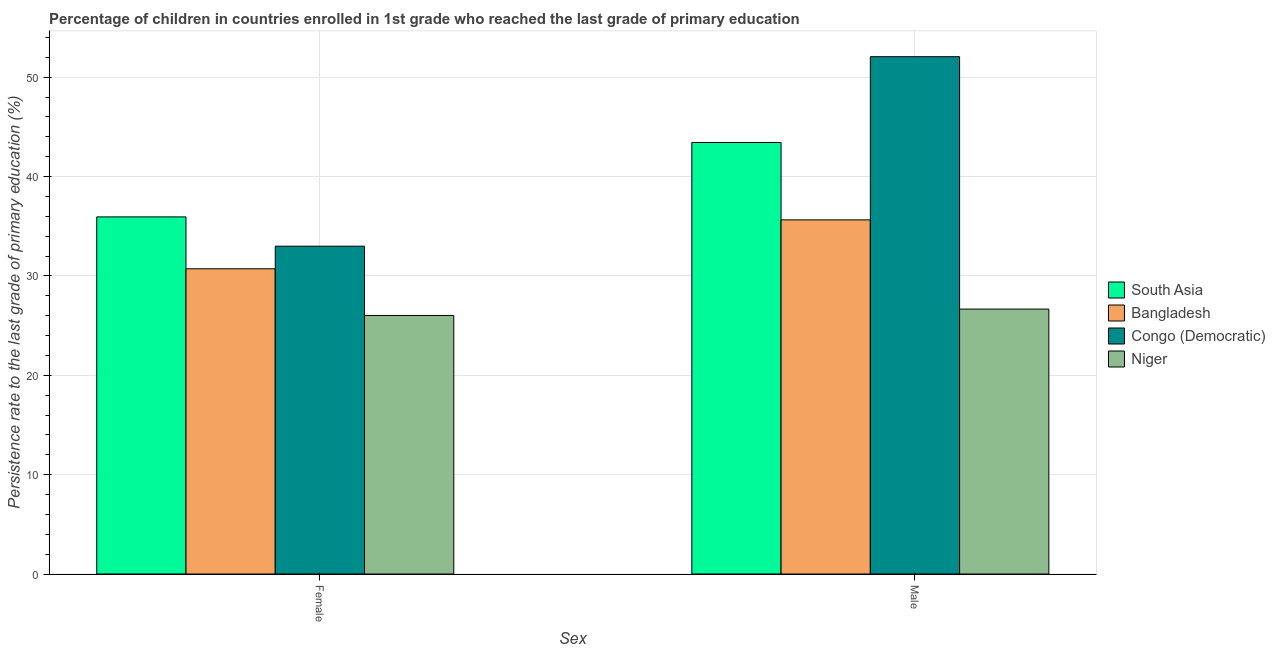Are the number of bars per tick equal to the number of legend labels?
Provide a short and direct response. Yes. What is the label of the 1st group of bars from the left?
Make the answer very short. Female. What is the persistence rate of female students in South Asia?
Offer a very short reply. 35.94. Across all countries, what is the maximum persistence rate of male students?
Keep it short and to the point. 52.06. Across all countries, what is the minimum persistence rate of female students?
Your response must be concise. 26.02. In which country was the persistence rate of female students maximum?
Provide a short and direct response. South Asia. In which country was the persistence rate of female students minimum?
Make the answer very short. Niger. What is the total persistence rate of male students in the graph?
Offer a terse response. 157.78. What is the difference between the persistence rate of female students in Bangladesh and that in Congo (Democratic)?
Make the answer very short. -2.27. What is the difference between the persistence rate of male students in Niger and the persistence rate of female students in Congo (Democratic)?
Make the answer very short. -6.33. What is the average persistence rate of male students per country?
Offer a terse response. 39.44. What is the difference between the persistence rate of female students and persistence rate of male students in Niger?
Provide a short and direct response. -0.64. In how many countries, is the persistence rate of male students greater than 10 %?
Your answer should be very brief. 4. What is the ratio of the persistence rate of male students in South Asia to that in Congo (Democratic)?
Ensure brevity in your answer.  0.83. Is the persistence rate of male students in South Asia less than that in Congo (Democratic)?
Ensure brevity in your answer.  Yes. In how many countries, is the persistence rate of male students greater than the average persistence rate of male students taken over all countries?
Your response must be concise. 2. What does the 1st bar from the left in Female represents?
Your response must be concise. South Asia. What does the 2nd bar from the right in Male represents?
Make the answer very short. Congo (Democratic). How many bars are there?
Your answer should be compact. 8. What is the difference between two consecutive major ticks on the Y-axis?
Your answer should be very brief. 10. Are the values on the major ticks of Y-axis written in scientific E-notation?
Give a very brief answer. No. How are the legend labels stacked?
Your answer should be very brief. Vertical. What is the title of the graph?
Your answer should be very brief. Percentage of children in countries enrolled in 1st grade who reached the last grade of primary education. Does "Middle East & North Africa (developing only)" appear as one of the legend labels in the graph?
Ensure brevity in your answer.  No. What is the label or title of the X-axis?
Give a very brief answer. Sex. What is the label or title of the Y-axis?
Keep it short and to the point. Persistence rate to the last grade of primary education (%). What is the Persistence rate to the last grade of primary education (%) of South Asia in Female?
Provide a short and direct response. 35.94. What is the Persistence rate to the last grade of primary education (%) in Bangladesh in Female?
Your answer should be very brief. 30.71. What is the Persistence rate to the last grade of primary education (%) of Congo (Democratic) in Female?
Provide a succinct answer. 32.99. What is the Persistence rate to the last grade of primary education (%) of Niger in Female?
Provide a succinct answer. 26.02. What is the Persistence rate to the last grade of primary education (%) in South Asia in Male?
Give a very brief answer. 43.42. What is the Persistence rate to the last grade of primary education (%) of Bangladesh in Male?
Provide a succinct answer. 35.64. What is the Persistence rate to the last grade of primary education (%) of Congo (Democratic) in Male?
Provide a short and direct response. 52.06. What is the Persistence rate to the last grade of primary education (%) of Niger in Male?
Provide a succinct answer. 26.66. Across all Sex, what is the maximum Persistence rate to the last grade of primary education (%) of South Asia?
Provide a succinct answer. 43.42. Across all Sex, what is the maximum Persistence rate to the last grade of primary education (%) in Bangladesh?
Provide a succinct answer. 35.64. Across all Sex, what is the maximum Persistence rate to the last grade of primary education (%) in Congo (Democratic)?
Your answer should be very brief. 52.06. Across all Sex, what is the maximum Persistence rate to the last grade of primary education (%) in Niger?
Ensure brevity in your answer.  26.66. Across all Sex, what is the minimum Persistence rate to the last grade of primary education (%) in South Asia?
Keep it short and to the point. 35.94. Across all Sex, what is the minimum Persistence rate to the last grade of primary education (%) of Bangladesh?
Ensure brevity in your answer.  30.71. Across all Sex, what is the minimum Persistence rate to the last grade of primary education (%) in Congo (Democratic)?
Ensure brevity in your answer.  32.99. Across all Sex, what is the minimum Persistence rate to the last grade of primary education (%) in Niger?
Ensure brevity in your answer.  26.02. What is the total Persistence rate to the last grade of primary education (%) in South Asia in the graph?
Keep it short and to the point. 79.36. What is the total Persistence rate to the last grade of primary education (%) in Bangladesh in the graph?
Offer a very short reply. 66.35. What is the total Persistence rate to the last grade of primary education (%) of Congo (Democratic) in the graph?
Your answer should be very brief. 85.04. What is the total Persistence rate to the last grade of primary education (%) of Niger in the graph?
Offer a very short reply. 52.68. What is the difference between the Persistence rate to the last grade of primary education (%) of South Asia in Female and that in Male?
Your answer should be very brief. -7.49. What is the difference between the Persistence rate to the last grade of primary education (%) of Bangladesh in Female and that in Male?
Offer a very short reply. -4.92. What is the difference between the Persistence rate to the last grade of primary education (%) in Congo (Democratic) in Female and that in Male?
Make the answer very short. -19.07. What is the difference between the Persistence rate to the last grade of primary education (%) of Niger in Female and that in Male?
Keep it short and to the point. -0.64. What is the difference between the Persistence rate to the last grade of primary education (%) of South Asia in Female and the Persistence rate to the last grade of primary education (%) of Bangladesh in Male?
Make the answer very short. 0.3. What is the difference between the Persistence rate to the last grade of primary education (%) of South Asia in Female and the Persistence rate to the last grade of primary education (%) of Congo (Democratic) in Male?
Your answer should be compact. -16.12. What is the difference between the Persistence rate to the last grade of primary education (%) of South Asia in Female and the Persistence rate to the last grade of primary education (%) of Niger in Male?
Give a very brief answer. 9.28. What is the difference between the Persistence rate to the last grade of primary education (%) of Bangladesh in Female and the Persistence rate to the last grade of primary education (%) of Congo (Democratic) in Male?
Provide a succinct answer. -21.34. What is the difference between the Persistence rate to the last grade of primary education (%) of Bangladesh in Female and the Persistence rate to the last grade of primary education (%) of Niger in Male?
Provide a short and direct response. 4.06. What is the difference between the Persistence rate to the last grade of primary education (%) in Congo (Democratic) in Female and the Persistence rate to the last grade of primary education (%) in Niger in Male?
Provide a succinct answer. 6.33. What is the average Persistence rate to the last grade of primary education (%) of South Asia per Sex?
Keep it short and to the point. 39.68. What is the average Persistence rate to the last grade of primary education (%) in Bangladesh per Sex?
Keep it short and to the point. 33.18. What is the average Persistence rate to the last grade of primary education (%) in Congo (Democratic) per Sex?
Offer a very short reply. 42.52. What is the average Persistence rate to the last grade of primary education (%) of Niger per Sex?
Provide a short and direct response. 26.34. What is the difference between the Persistence rate to the last grade of primary education (%) in South Asia and Persistence rate to the last grade of primary education (%) in Bangladesh in Female?
Provide a succinct answer. 5.22. What is the difference between the Persistence rate to the last grade of primary education (%) in South Asia and Persistence rate to the last grade of primary education (%) in Congo (Democratic) in Female?
Offer a terse response. 2.95. What is the difference between the Persistence rate to the last grade of primary education (%) in South Asia and Persistence rate to the last grade of primary education (%) in Niger in Female?
Ensure brevity in your answer.  9.92. What is the difference between the Persistence rate to the last grade of primary education (%) in Bangladesh and Persistence rate to the last grade of primary education (%) in Congo (Democratic) in Female?
Your response must be concise. -2.27. What is the difference between the Persistence rate to the last grade of primary education (%) in Bangladesh and Persistence rate to the last grade of primary education (%) in Niger in Female?
Your answer should be very brief. 4.7. What is the difference between the Persistence rate to the last grade of primary education (%) in Congo (Democratic) and Persistence rate to the last grade of primary education (%) in Niger in Female?
Ensure brevity in your answer.  6.97. What is the difference between the Persistence rate to the last grade of primary education (%) in South Asia and Persistence rate to the last grade of primary education (%) in Bangladesh in Male?
Give a very brief answer. 7.79. What is the difference between the Persistence rate to the last grade of primary education (%) in South Asia and Persistence rate to the last grade of primary education (%) in Congo (Democratic) in Male?
Your response must be concise. -8.63. What is the difference between the Persistence rate to the last grade of primary education (%) in South Asia and Persistence rate to the last grade of primary education (%) in Niger in Male?
Your answer should be very brief. 16.76. What is the difference between the Persistence rate to the last grade of primary education (%) in Bangladesh and Persistence rate to the last grade of primary education (%) in Congo (Democratic) in Male?
Provide a short and direct response. -16.42. What is the difference between the Persistence rate to the last grade of primary education (%) of Bangladesh and Persistence rate to the last grade of primary education (%) of Niger in Male?
Your answer should be very brief. 8.98. What is the difference between the Persistence rate to the last grade of primary education (%) in Congo (Democratic) and Persistence rate to the last grade of primary education (%) in Niger in Male?
Offer a very short reply. 25.4. What is the ratio of the Persistence rate to the last grade of primary education (%) in South Asia in Female to that in Male?
Keep it short and to the point. 0.83. What is the ratio of the Persistence rate to the last grade of primary education (%) in Bangladesh in Female to that in Male?
Make the answer very short. 0.86. What is the ratio of the Persistence rate to the last grade of primary education (%) in Congo (Democratic) in Female to that in Male?
Provide a succinct answer. 0.63. What is the difference between the highest and the second highest Persistence rate to the last grade of primary education (%) of South Asia?
Your answer should be very brief. 7.49. What is the difference between the highest and the second highest Persistence rate to the last grade of primary education (%) in Bangladesh?
Your response must be concise. 4.92. What is the difference between the highest and the second highest Persistence rate to the last grade of primary education (%) of Congo (Democratic)?
Give a very brief answer. 19.07. What is the difference between the highest and the second highest Persistence rate to the last grade of primary education (%) in Niger?
Give a very brief answer. 0.64. What is the difference between the highest and the lowest Persistence rate to the last grade of primary education (%) in South Asia?
Provide a short and direct response. 7.49. What is the difference between the highest and the lowest Persistence rate to the last grade of primary education (%) of Bangladesh?
Provide a short and direct response. 4.92. What is the difference between the highest and the lowest Persistence rate to the last grade of primary education (%) of Congo (Democratic)?
Provide a succinct answer. 19.07. What is the difference between the highest and the lowest Persistence rate to the last grade of primary education (%) of Niger?
Your answer should be compact. 0.64. 